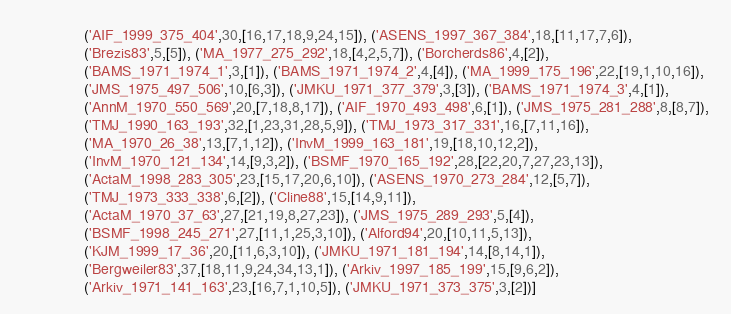Convert code to text. <code><loc_0><loc_0><loc_500><loc_500><_Python_>               ('AIF_1999_375_404',30,[16,17,18,9,24,15]), ('ASENS_1997_367_384',18,[11,17,7,6]),
               ('Brezis83',5,[5]), ('MA_1977_275_292',18,[4,2,5,7]), ('Borcherds86',4,[2]),
               ('BAMS_1971_1974_1',3,[1]), ('BAMS_1971_1974_2',4,[4]), ('MA_1999_175_196',22,[19,1,10,16]),
               ('JMS_1975_497_506',10,[6,3]), ('JMKU_1971_377_379',3,[3]), ('BAMS_1971_1974_3',4,[1]),
               ('AnnM_1970_550_569',20,[7,18,8,17]), ('AIF_1970_493_498',6,[1]), ('JMS_1975_281_288',8,[8,7]),
               ('TMJ_1990_163_193',32,[1,23,31,28,5,9]), ('TMJ_1973_317_331',16,[7,11,16]),
               ('MA_1970_26_38',13,[7,1,12]), ('InvM_1999_163_181',19,[18,10,12,2]),
               ('InvM_1970_121_134',14,[9,3,2]), ('BSMF_1970_165_192',28,[22,20,7,27,23,13]),
               ('ActaM_1998_283_305',23,[15,17,20,6,10]), ('ASENS_1970_273_284',12,[5,7]),
               ('TMJ_1973_333_338',6,[2]), ('Cline88',15,[14,9,11]),
               ('ActaM_1970_37_63',27,[21,19,8,27,23]), ('JMS_1975_289_293',5,[4]),
               ('BSMF_1998_245_271',27,[11,1,25,3,10]), ('Alford94',20,[10,11,5,13]),
               ('KJM_1999_17_36',20,[11,6,3,10]), ('JMKU_1971_181_194',14,[8,14,1]),
               ('Bergweiler83',37,[18,11,9,24,34,13,1]), ('Arkiv_1997_185_199',15,[9,6,2]),
               ('Arkiv_1971_141_163',23,[16,7,1,10,5]), ('JMKU_1971_373_375',3,[2])]
</code> 